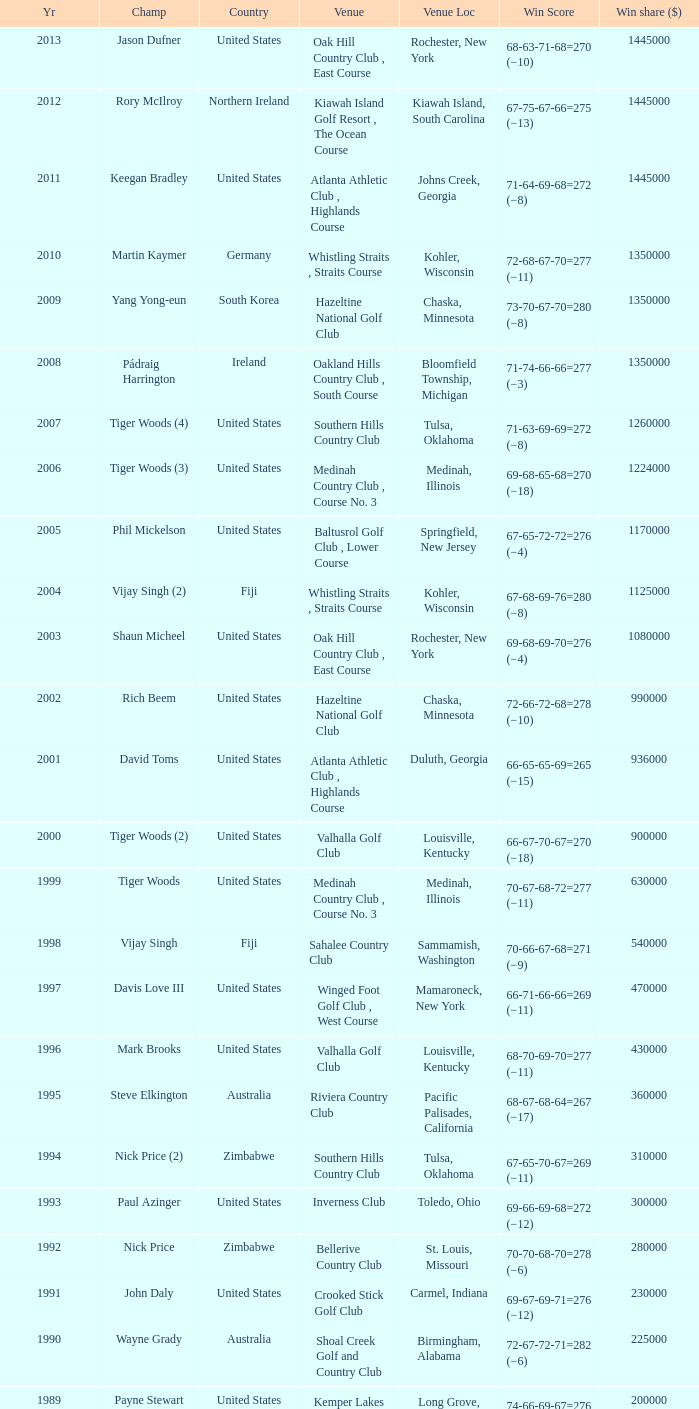Where is the Bellerive Country Club venue located? St. Louis, Missouri. 